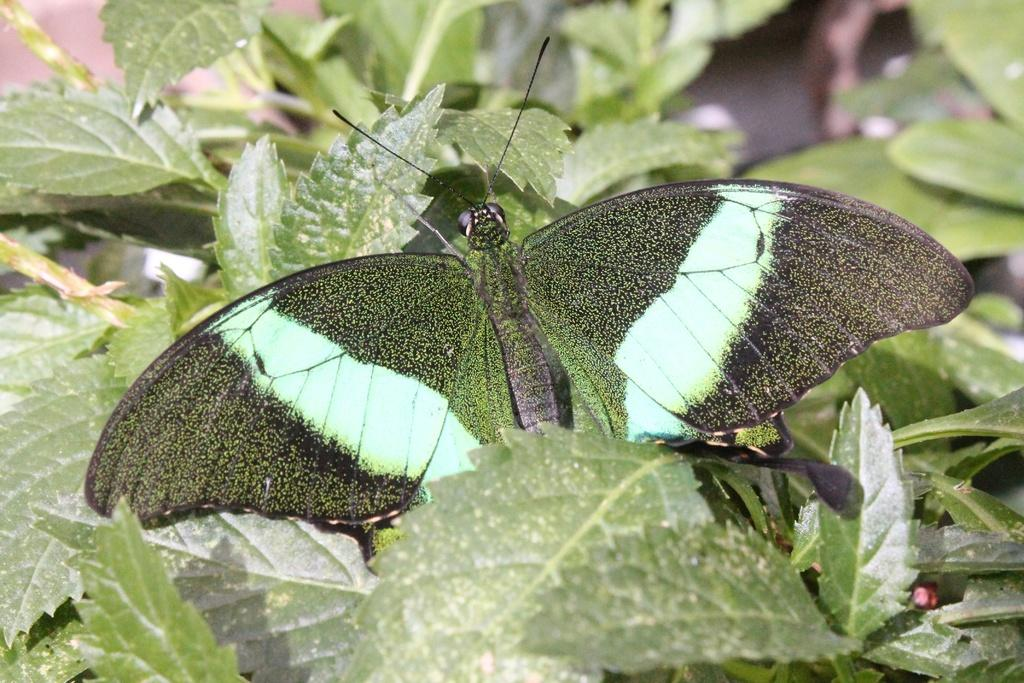What type of living organisms can be seen in the image? Plants and a butterfly are visible in the image. Can you describe the butterfly in the image? The butterfly in the image is likely a colorful insect with wings. What type of manager is overseeing the birthday party in the image? There is no manager or birthday party present in the image; it features plants and a butterfly. What type of celery is being used as a decoration in the image? There is no celery present in the image. 